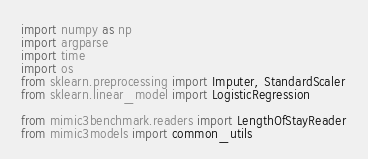Convert code to text. <code><loc_0><loc_0><loc_500><loc_500><_Python_>import numpy as np
import argparse
import time
import os
from sklearn.preprocessing import Imputer, StandardScaler
from sklearn.linear_model import LogisticRegression

from mimic3benchmark.readers import LengthOfStayReader
from mimic3models import common_utils</code> 